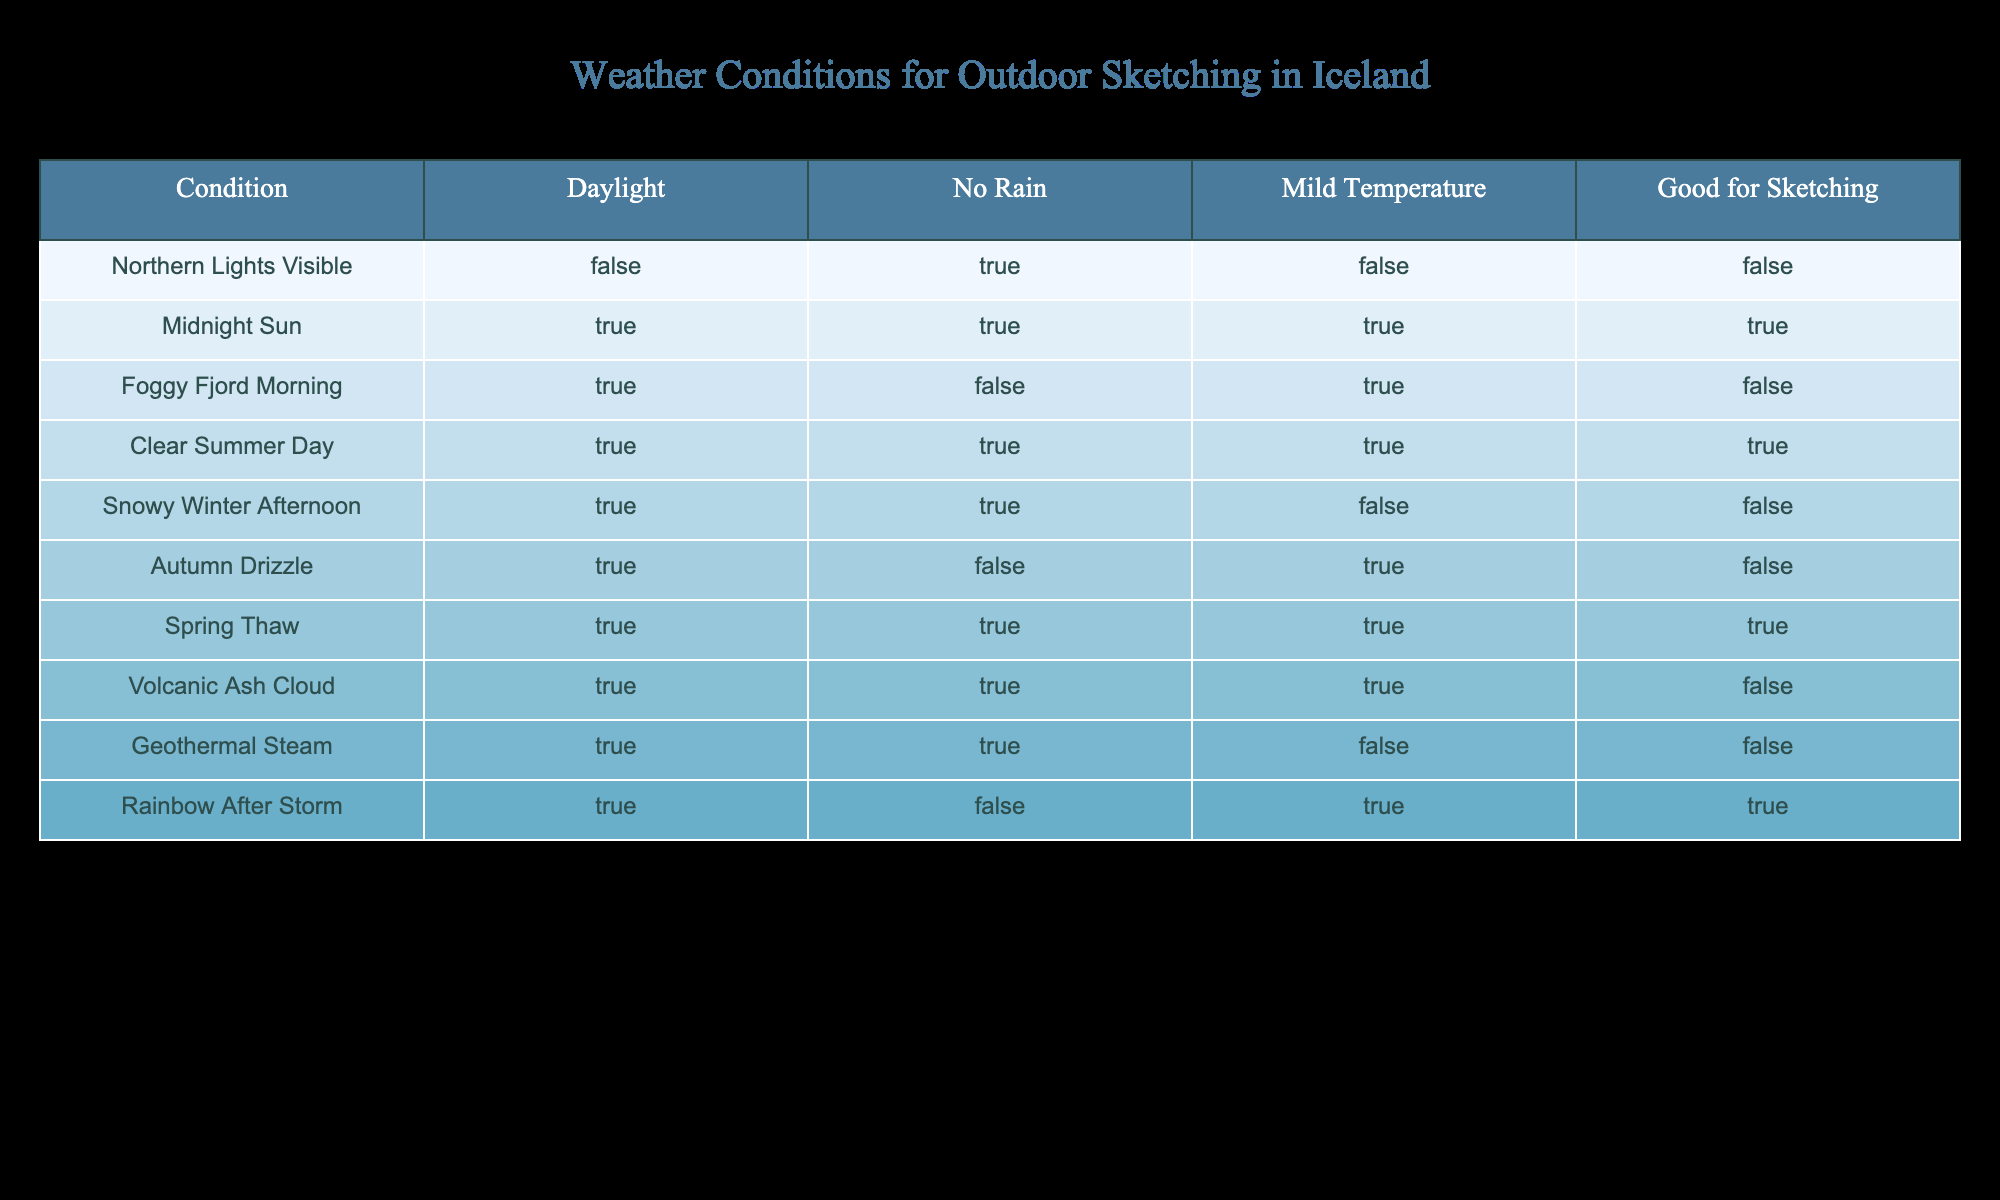What weather condition allows for outdoor sketching? The table shows that the conditions which are "Good for Sketching" are represented by "TRUE". Looking down the "Good for Sketching" column, the conditions that meet this criterion are "Midnight Sun," "Clear Summer Day," "Spring Thaw," and "Rainbow After Storm."
Answer: Midnight Sun, Clear Summer Day, Spring Thaw, Rainbow After Storm Is it possible to sketch during a foggy morning in the fjords? Referring to the "Foggy Fjord Morning" condition in the table, it shows that while it's daylight (TRUE) and there is no rain (FALSE), the "Good for Sketching" column indicates FALSE. Therefore, it is not possible to sketch.
Answer: No How many total conditions have no rain and are suitable for sketching? We need to filter the "No Rain" column for TRUE and then check if "Good for Sketching" is also TRUE. The only conditions that meet both criteria are "Clear Summer Day" and "Spring Thaw." Thus, there are two such conditions.
Answer: 2 Which conditions occur during the daylight but are not suitable for sketching? By examining the table for conditions marked TRUE in the "Daylight" column, we can look for records where "Good for Sketching" is FALSE. The conditions "Foggy Fjord Morning," "Snowy Winter Afternoon," and "Autumn Drizzle" fulfill this criterion during daylight but are not suitable for sketching.
Answer: Foggy Fjord Morning, Snowy Winter Afternoon, Autumn Drizzle Is the presence of the Northern Lights during the day a good indication for sketching? Evaluating the table, the "Northern Lights Visible" condition indicates daylight as FALSE, meaning it occurs at night. The "Good for Sketching" entry for this condition is also FALSE, meaning even though it is visually spectacular, it isn’t suitable for sketching.
Answer: No 